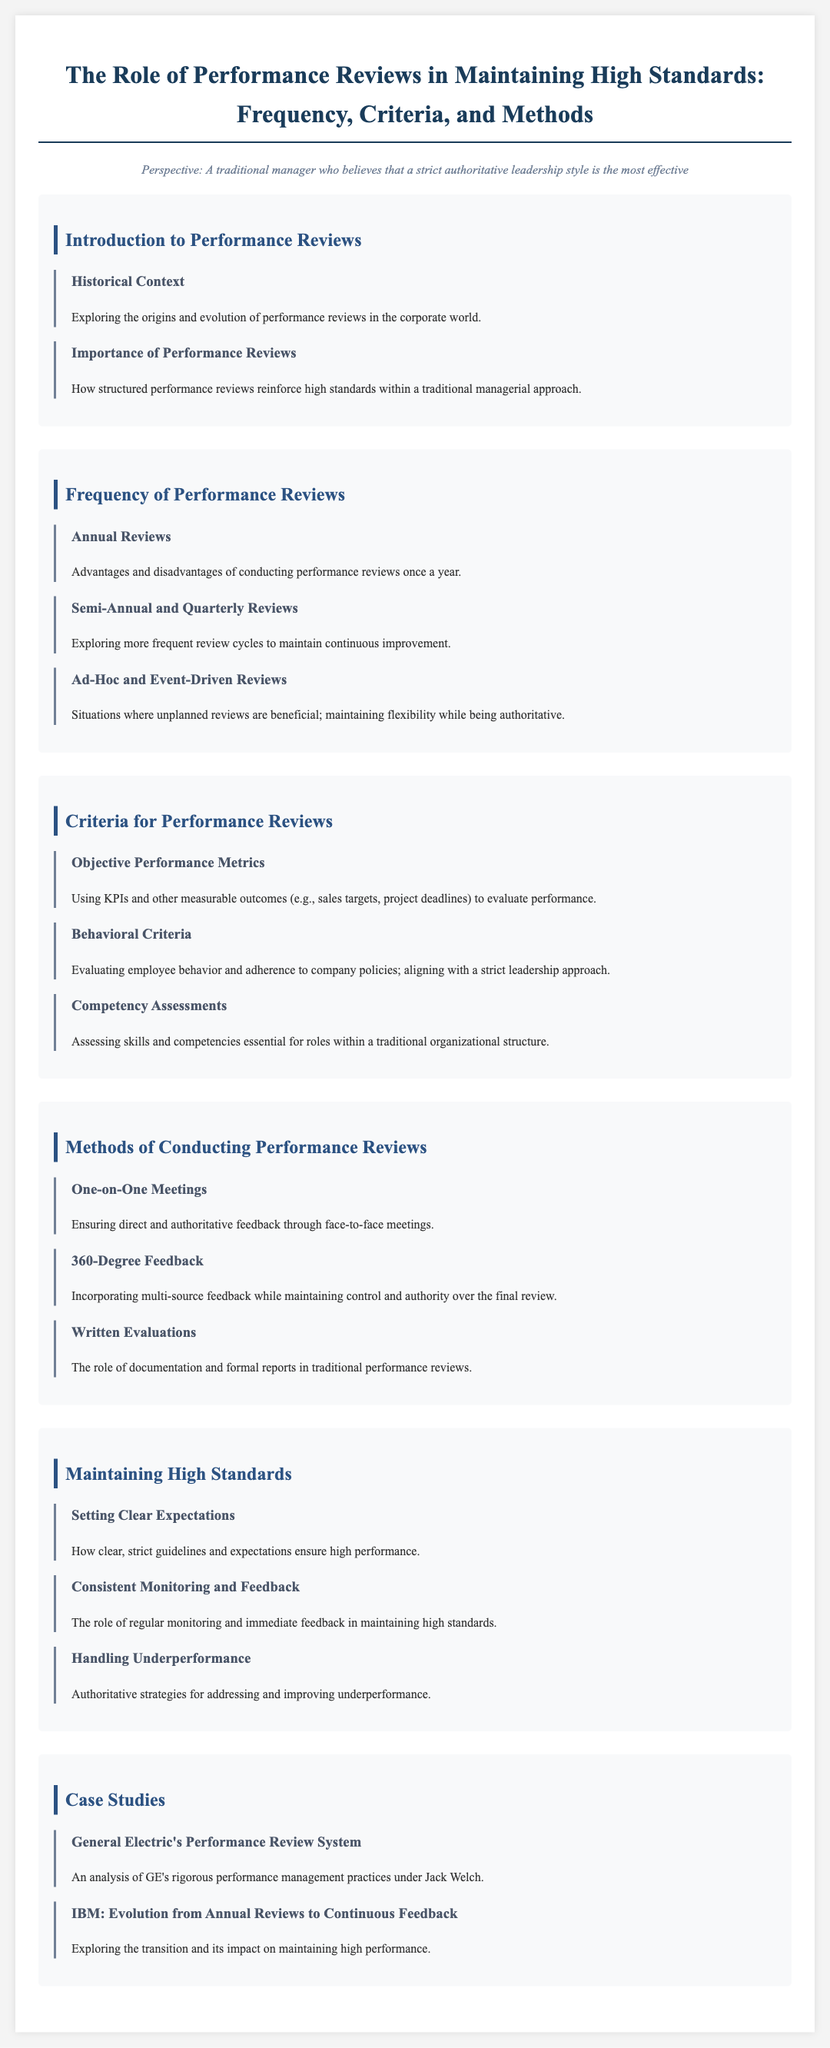What is the title of the syllabus? The title is the main heading of the document, which is displayed prominently at the top.
Answer: The Role of Performance Reviews in Maintaining High Standards: Frequency, Criteria, and Methods What sections are included in the syllabus? The sections are the main topics or modules outlined in the document, which structure the information.
Answer: Introduction to Performance Reviews, Frequency of Performance Reviews, Criteria for Performance Reviews, Methods of Conducting Performance Reviews, Maintaining High Standards, Case Studies What is one advantage of annual reviews? This information can typically include benefits associated with conducting reviews annually.
Answer: Advantages and disadvantages of conducting performance reviews once a year What method emphasizes direct feedback? This refers to a specific approach detailed in the Methods section that enables authoritative communication.
Answer: One-on-One Meetings Which company is analyzed for its performance management practices? This is a specific example provided in the Case Studies section regarding a company's approach to performance evaluations.
Answer: General Electric What is assessed to evaluate employees' adherence to policies? This pertains to the criteria used for evaluating employee performance, specifically behavior-related measures.
Answer: Behavioral Criteria What are the two types of reviews mentioned for frequency? These terms specify the frequency of performance evaluations discussed in the syllabus.
Answer: Semi-Annual and Quarterly Reviews What role does documentation play in performance reviews? This highlights the significance of written records and evaluations as part of the review process.
Answer: The role of documentation and formal reports in traditional performance reviews 